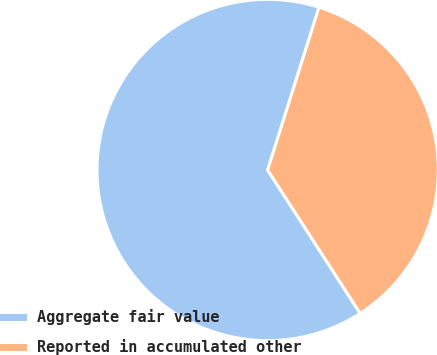Convert chart to OTSL. <chart><loc_0><loc_0><loc_500><loc_500><pie_chart><fcel>Aggregate fair value<fcel>Reported in accumulated other<nl><fcel>63.99%<fcel>36.01%<nl></chart> 